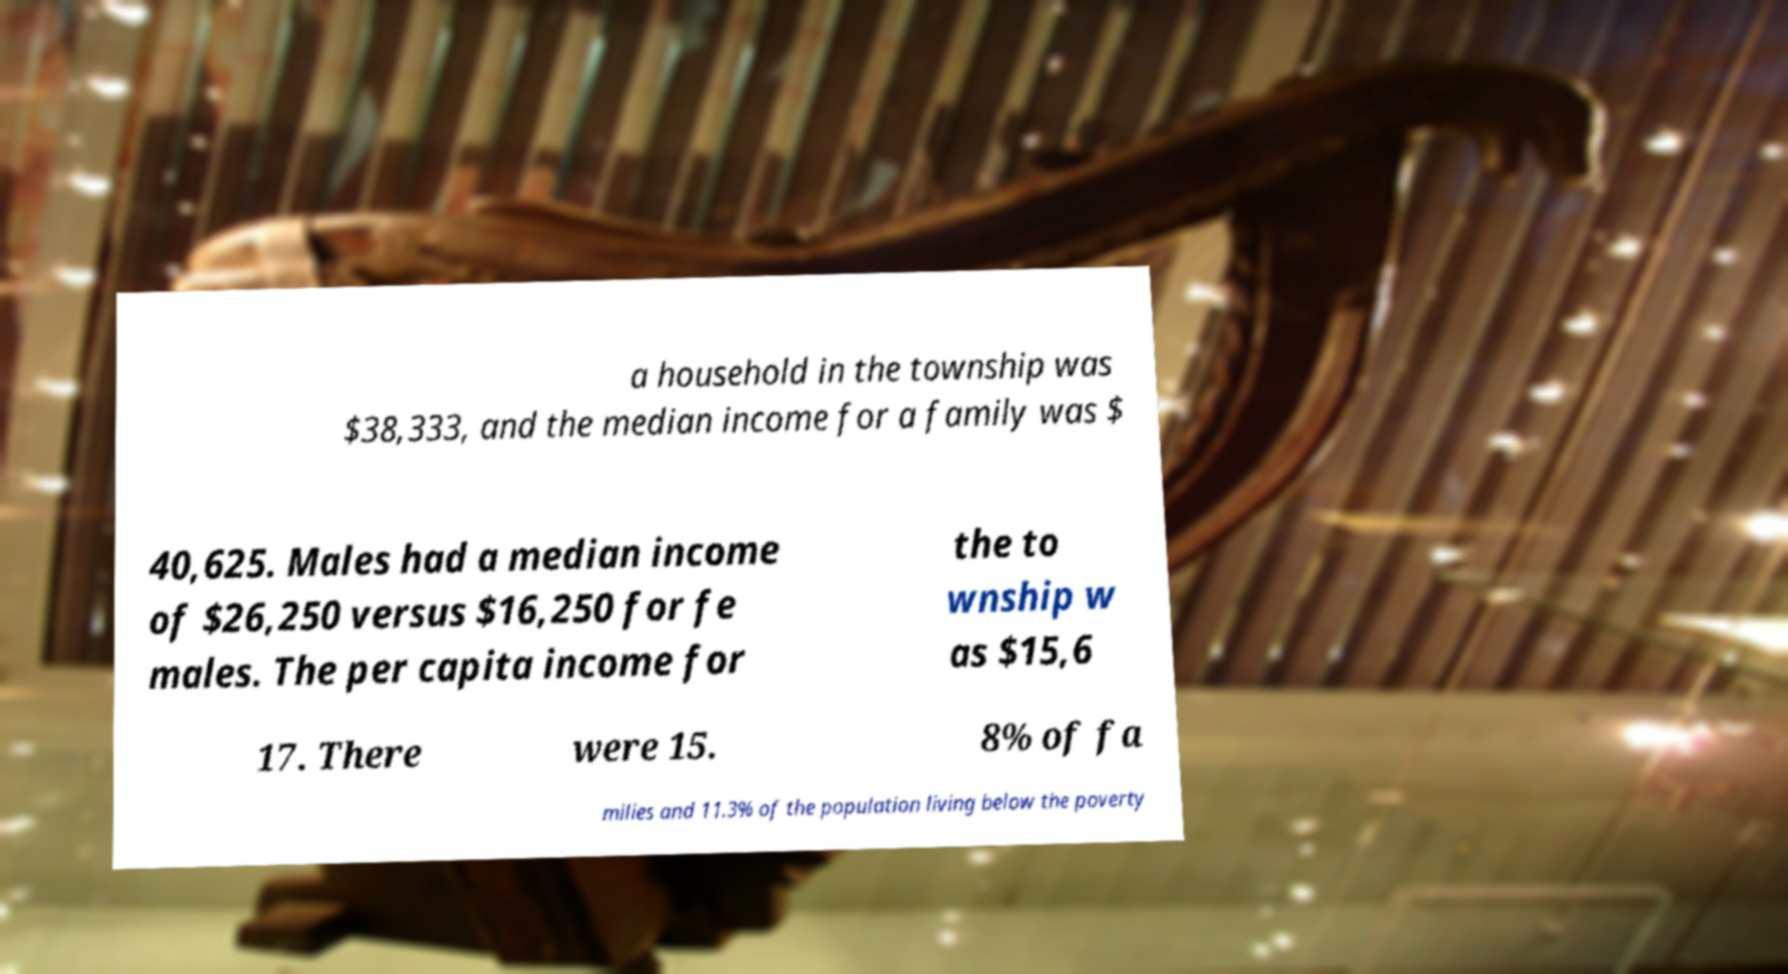For documentation purposes, I need the text within this image transcribed. Could you provide that? a household in the township was $38,333, and the median income for a family was $ 40,625. Males had a median income of $26,250 versus $16,250 for fe males. The per capita income for the to wnship w as $15,6 17. There were 15. 8% of fa milies and 11.3% of the population living below the poverty 